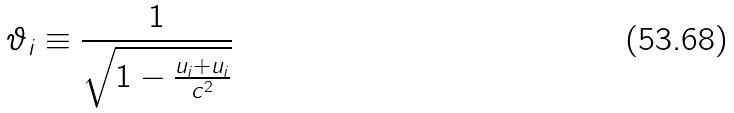<formula> <loc_0><loc_0><loc_500><loc_500>\vartheta _ { i } \equiv \frac { 1 } { \sqrt { 1 - \frac { u _ { i } + u _ { i } } { c ^ { 2 } } } }</formula> 